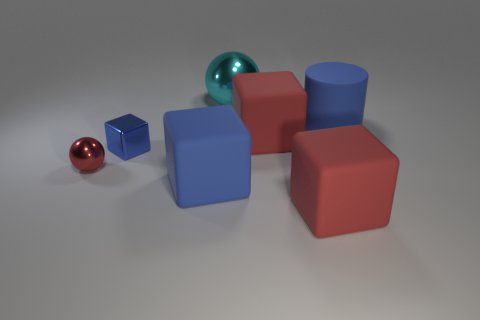Subtract all red balls. How many red blocks are left? 2 Subtract all small metallic cubes. How many cubes are left? 3 Add 2 brown rubber things. How many objects exist? 9 Subtract all gray blocks. Subtract all purple spheres. How many blocks are left? 4 Subtract all cylinders. How many objects are left? 6 Add 7 purple balls. How many purple balls exist? 7 Subtract 0 purple cylinders. How many objects are left? 7 Subtract all large matte cylinders. Subtract all big cyan metal spheres. How many objects are left? 5 Add 7 tiny red metallic spheres. How many tiny red metallic spheres are left? 8 